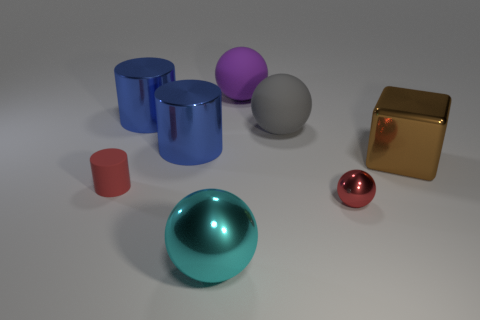Subtract all red spheres. How many blue cylinders are left? 2 Subtract all rubber cylinders. How many cylinders are left? 2 Subtract 1 spheres. How many spheres are left? 3 Add 1 cyan metallic cubes. How many objects exist? 9 Subtract all gray balls. How many balls are left? 3 Subtract all purple spheres. Subtract all purple blocks. How many spheres are left? 3 Subtract all blocks. How many objects are left? 7 Add 5 big purple rubber cubes. How many big purple rubber cubes exist? 5 Subtract 0 yellow blocks. How many objects are left? 8 Subtract all blue metallic spheres. Subtract all red matte things. How many objects are left? 7 